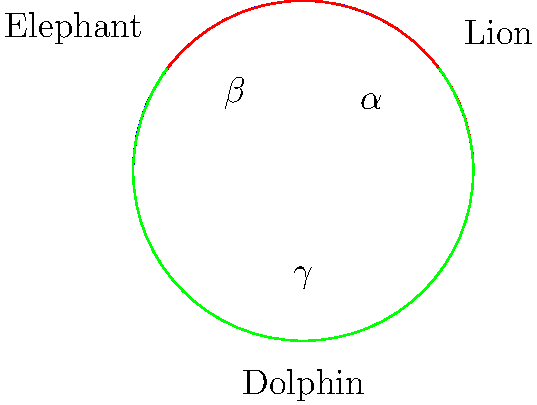For an upcoming global advertising campaign, you've trained a lion, an elephant, and a dolphin to perform at specific locations on Earth. Their positions form a spherical triangle on the globe. The internal angles of this triangle are measured to be $\alpha = 100°$, $\beta = 120°$, and $\gamma = 90°$. What is the area of this spherical triangle in square degrees? To solve this problem, we'll use the formula for the area of a spherical triangle:

1) The area $A$ of a spherical triangle is given by the formula:
   $$A = (\alpha + \beta + \gamma - 180°) \cdot R^2$$
   where $R$ is the radius of the sphere in radians.

2) For a unit sphere (which is what we use when measuring in square degrees), $R = 1$ radian.

3) Substituting the given angles:
   $$A = (100° + 120° + 90° - 180°) \cdot 1^2$$

4) Simplifying:
   $$A = (310° - 180°) \cdot 1 = 130°$$

5) Therefore, the area of the spherical triangle is 130 square degrees.

Note: This result demonstrates a key difference between Euclidean and non-Euclidean geometry. In Euclidean geometry, the sum of angles in a triangle is always 180°, but in spherical geometry, it's always greater than 180°.
Answer: 130 square degrees 